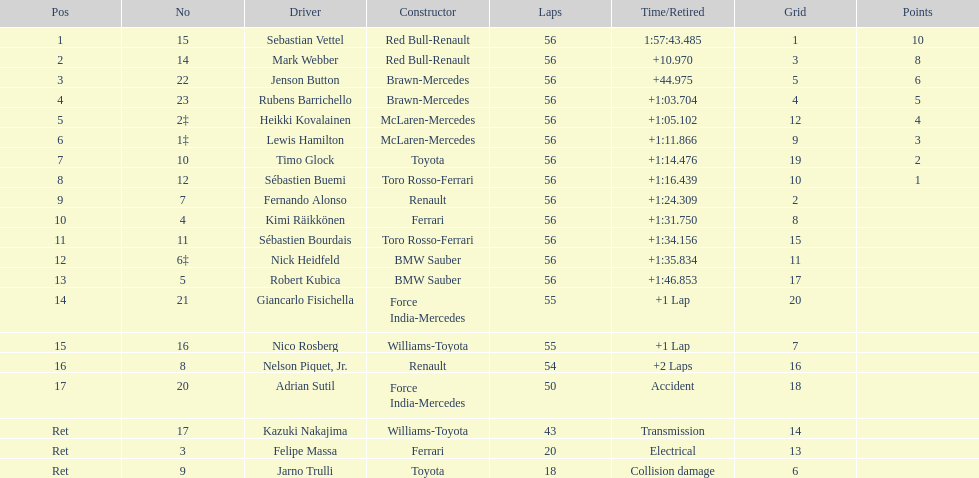What was jenson button's duration? +44.975. 